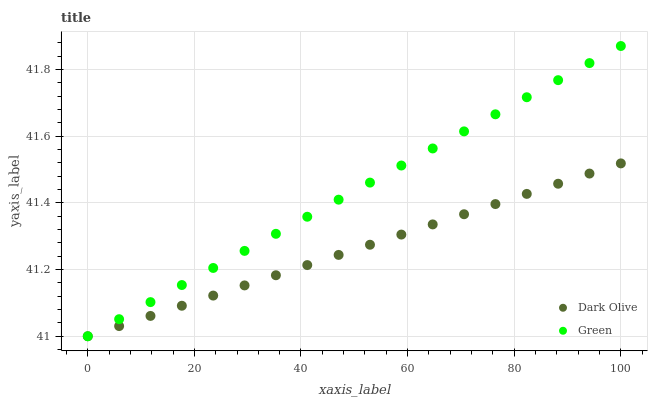Does Dark Olive have the minimum area under the curve?
Answer yes or no. Yes. Does Green have the maximum area under the curve?
Answer yes or no. Yes. Does Green have the minimum area under the curve?
Answer yes or no. No. Is Dark Olive the smoothest?
Answer yes or no. Yes. Is Green the roughest?
Answer yes or no. Yes. Is Green the smoothest?
Answer yes or no. No. Does Dark Olive have the lowest value?
Answer yes or no. Yes. Does Green have the highest value?
Answer yes or no. Yes. Does Green intersect Dark Olive?
Answer yes or no. Yes. Is Green less than Dark Olive?
Answer yes or no. No. Is Green greater than Dark Olive?
Answer yes or no. No. 